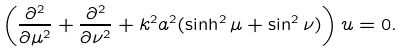<formula> <loc_0><loc_0><loc_500><loc_500>\left ( \frac { \partial ^ { 2 } } { \partial \mu ^ { 2 } } + \frac { \partial ^ { 2 } } { \partial \nu ^ { 2 } } + k ^ { 2 } a ^ { 2 } ( \sinh ^ { 2 } \mu + \sin ^ { 2 } \nu ) \right ) u = 0 .</formula> 